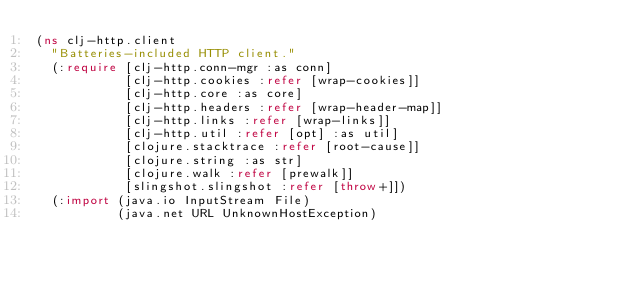Convert code to text. <code><loc_0><loc_0><loc_500><loc_500><_Clojure_>(ns clj-http.client
  "Batteries-included HTTP client."
  (:require [clj-http.conn-mgr :as conn]
            [clj-http.cookies :refer [wrap-cookies]]
            [clj-http.core :as core]
            [clj-http.headers :refer [wrap-header-map]]
            [clj-http.links :refer [wrap-links]]
            [clj-http.util :refer [opt] :as util]
            [clojure.stacktrace :refer [root-cause]]
            [clojure.string :as str]
            [clojure.walk :refer [prewalk]]
            [slingshot.slingshot :refer [throw+]])
  (:import (java.io InputStream File)
           (java.net URL UnknownHostException)</code> 